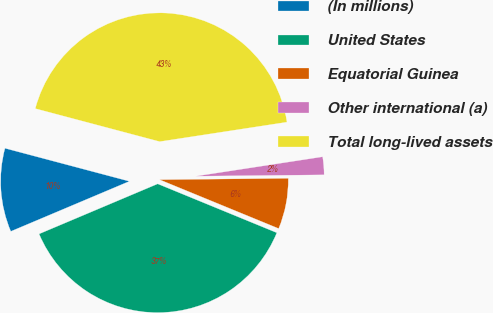Convert chart to OTSL. <chart><loc_0><loc_0><loc_500><loc_500><pie_chart><fcel>(In millions)<fcel>United States<fcel>Equatorial Guinea<fcel>Other international (a)<fcel>Total long-lived assets<nl><fcel>10.49%<fcel>37.44%<fcel>6.37%<fcel>2.25%<fcel>43.45%<nl></chart> 